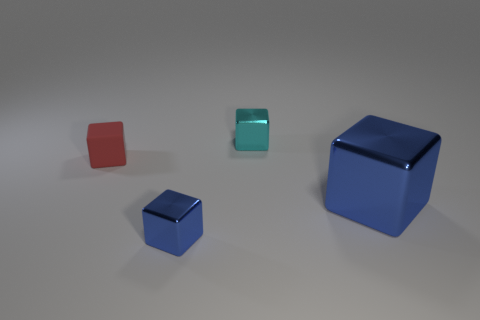What number of big things are in front of the large cube?
Offer a terse response. 0. There is a small cube that is the same color as the big block; what material is it?
Keep it short and to the point. Metal. What number of tiny things are rubber cubes or green metallic cylinders?
Keep it short and to the point. 1. What is the shape of the tiny thing behind the small red matte thing?
Give a very brief answer. Cube. Is there a big metal cube of the same color as the matte block?
Offer a very short reply. No. There is a cyan shiny cube to the right of the small red block; does it have the same size as the blue block to the left of the tiny cyan cube?
Your answer should be compact. Yes. Are there more small cyan cubes that are in front of the tiny red matte block than cyan metallic things on the left side of the big metallic cube?
Offer a very short reply. No. Are there any tiny cylinders made of the same material as the small blue cube?
Provide a short and direct response. No. Is the color of the big metal thing the same as the rubber cube?
Make the answer very short. No. The thing that is both in front of the red block and to the left of the large blue metal cube is made of what material?
Your response must be concise. Metal. 